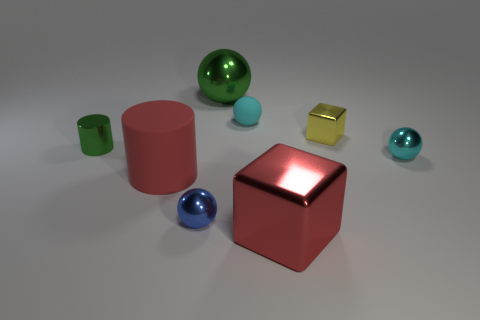Subtract all purple balls. Subtract all cyan cubes. How many balls are left? 4 Subtract all green blocks. How many brown cylinders are left? 0 Add 6 large greens. How many things exist? 0 Subtract all small cyan shiny balls. Subtract all small blue metal things. How many objects are left? 6 Add 7 small yellow cubes. How many small yellow cubes are left? 8 Add 5 small cylinders. How many small cylinders exist? 6 Add 2 tiny things. How many objects exist? 10 Subtract all red blocks. How many blocks are left? 1 Subtract all cyan rubber balls. How many balls are left? 3 Subtract 0 blue cylinders. How many objects are left? 8 